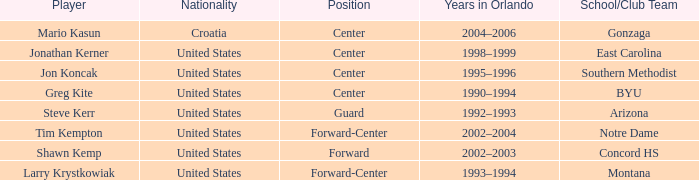Would you mind parsing the complete table? {'header': ['Player', 'Nationality', 'Position', 'Years in Orlando', 'School/Club Team'], 'rows': [['Mario Kasun', 'Croatia', 'Center', '2004–2006', 'Gonzaga'], ['Jonathan Kerner', 'United States', 'Center', '1998–1999', 'East Carolina'], ['Jon Koncak', 'United States', 'Center', '1995–1996', 'Southern Methodist'], ['Greg Kite', 'United States', 'Center', '1990–1994', 'BYU'], ['Steve Kerr', 'United States', 'Guard', '1992–1993', 'Arizona'], ['Tim Kempton', 'United States', 'Forward-Center', '2002–2004', 'Notre Dame'], ['Shawn Kemp', 'United States', 'Forward', '2002–2003', 'Concord HS'], ['Larry Krystkowiak', 'United States', 'Forward-Center', '1993–1994', 'Montana']]} Which player has montana as the school/club team? Larry Krystkowiak. 